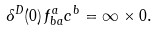Convert formula to latex. <formula><loc_0><loc_0><loc_500><loc_500>\delta ^ { D } ( 0 ) \, f ^ { a } _ { b a } c ^ { b } = \infty \times 0 .</formula> 